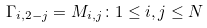<formula> <loc_0><loc_0><loc_500><loc_500>\Gamma _ { i , 2 - j } = M _ { i , j } \colon 1 \leq i , j \leq N</formula> 